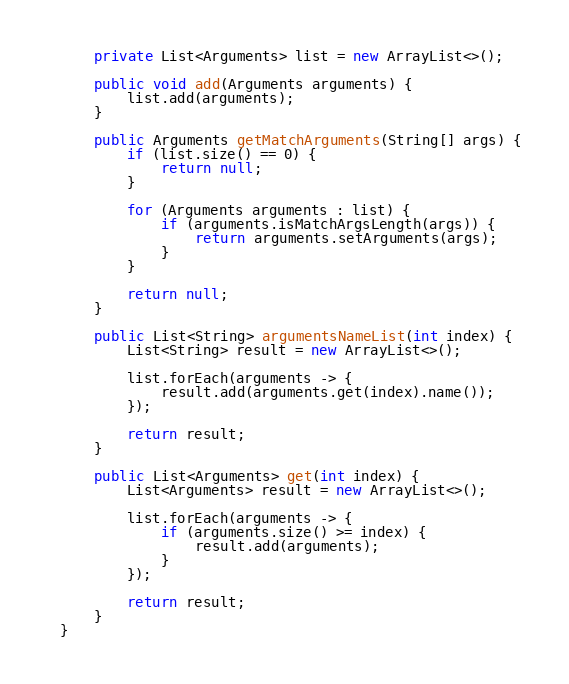<code> <loc_0><loc_0><loc_500><loc_500><_Java_>    private List<Arguments> list = new ArrayList<>();

    public void add(Arguments arguments) {
        list.add(arguments);
    }

    public Arguments getMatchArguments(String[] args) {
        if (list.size() == 0) {
            return null;
        }

        for (Arguments arguments : list) {
            if (arguments.isMatchArgsLength(args)) {
                return arguments.setArguments(args);
            }
        }

        return null;
    }

    public List<String> argumentsNameList(int index) {
        List<String> result = new ArrayList<>();

        list.forEach(arguments -> {
            result.add(arguments.get(index).name());
        });

        return result;
    }

    public List<Arguments> get(int index) {
        List<Arguments> result = new ArrayList<>();

        list.forEach(arguments -> {
            if (arguments.size() >= index) {
                result.add(arguments);
            }
        });

        return result;
    }
}
</code> 